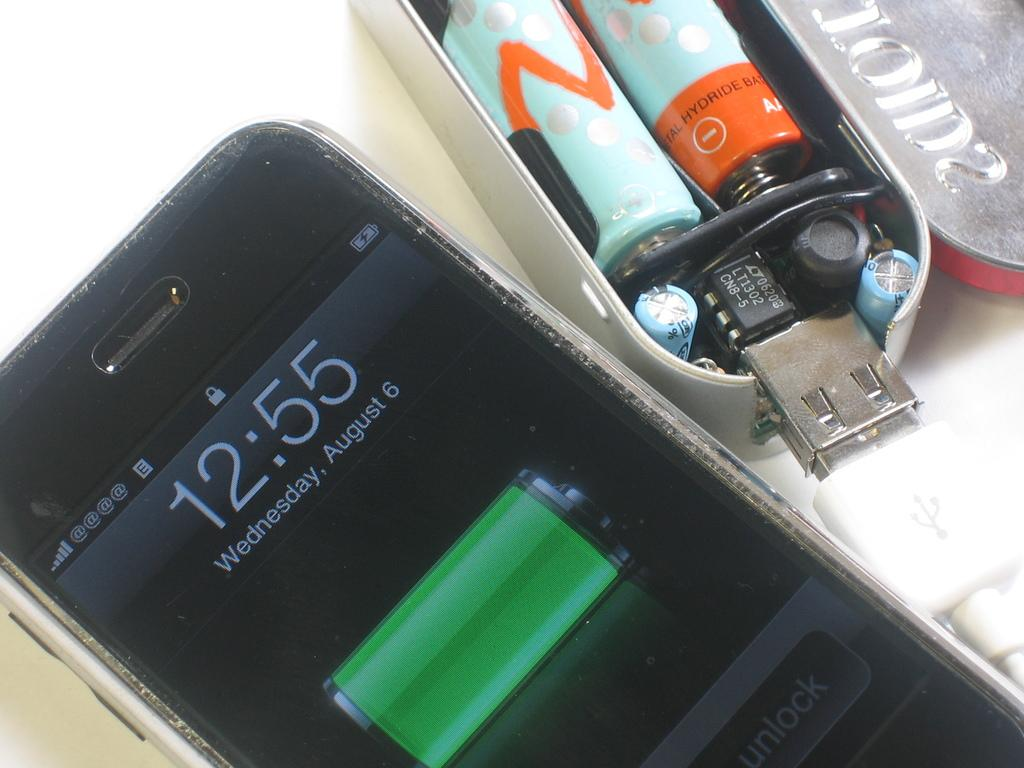<image>
Give a short and clear explanation of the subsequent image. An iphone lock screen that says 12:55 next to an open, battery powered USB drive to the right side. 